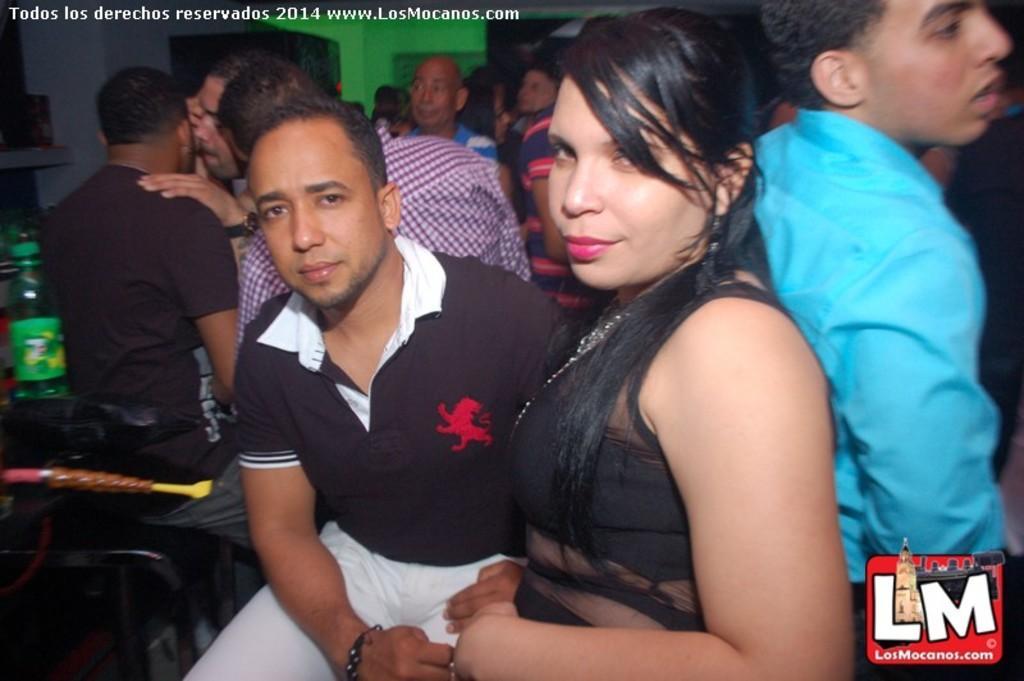Please provide a concise description of this image. In this picture there is a woman who is wearing black dress. Besides her we can see a man who is wearing black t-shirt and white trouser. On the right there is another man who is wearing blue shirt. On the background we can see group of persons are standing. On the left there is a bottle on the table. On the top left corner and bottom right corner there is a watermark. 